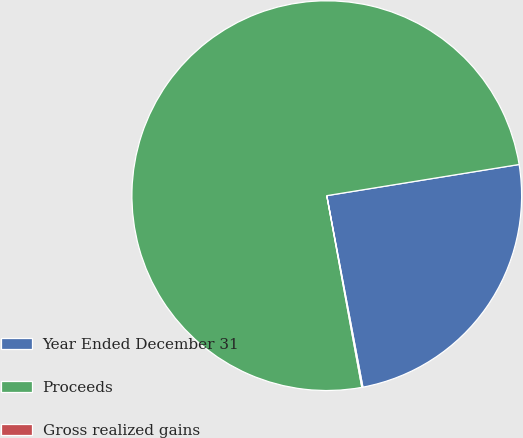<chart> <loc_0><loc_0><loc_500><loc_500><pie_chart><fcel>Year Ended December 31<fcel>Proceeds<fcel>Gross realized gains<nl><fcel>24.59%<fcel>75.33%<fcel>0.09%<nl></chart> 